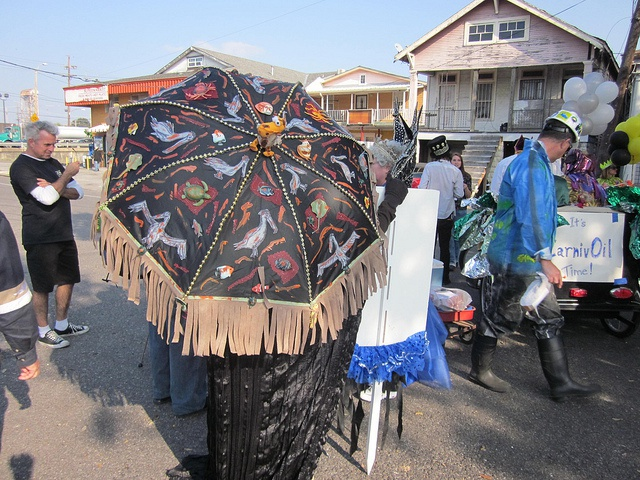Describe the objects in this image and their specific colors. I can see umbrella in lightblue, gray, tan, darkgray, and black tones, people in lightblue, black, gray, and blue tones, people in lightblue, black, gray, and darkgray tones, people in lightblue, gray, white, black, and tan tones, and people in lightblue, black, darkblue, and gray tones in this image. 